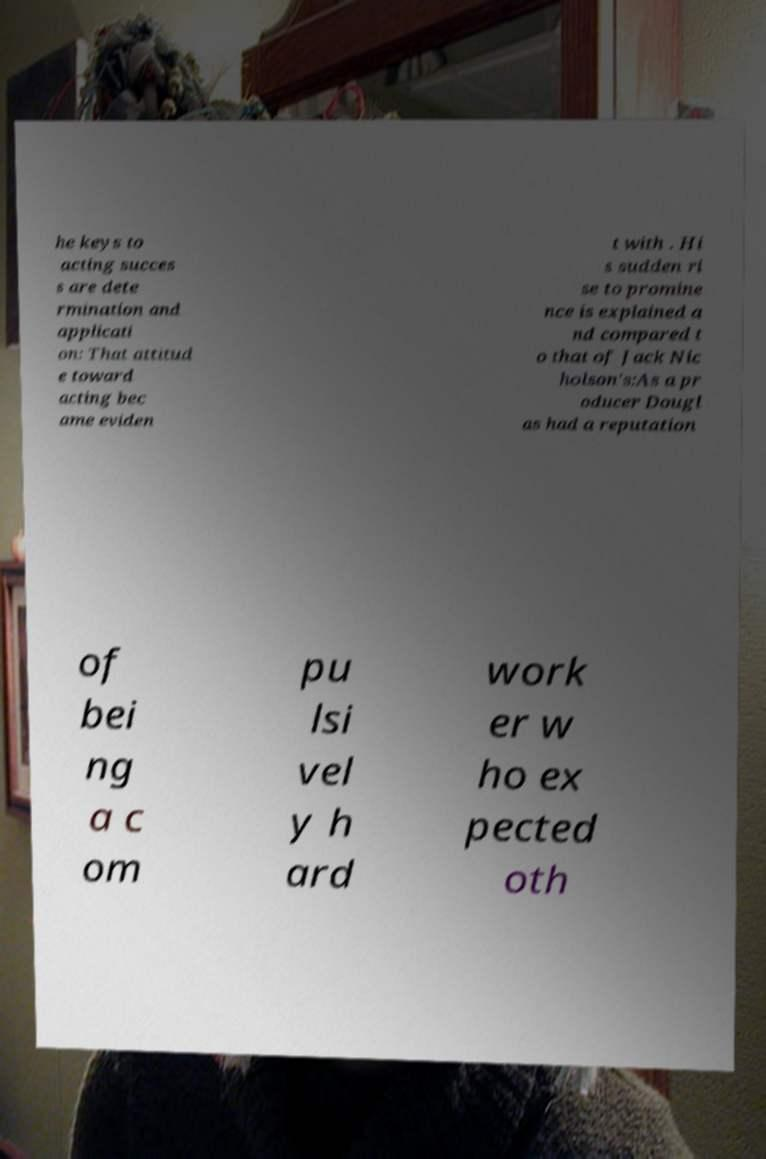What messages or text are displayed in this image? I need them in a readable, typed format. he keys to acting succes s are dete rmination and applicati on: That attitud e toward acting bec ame eviden t with . Hi s sudden ri se to promine nce is explained a nd compared t o that of Jack Nic holson's:As a pr oducer Dougl as had a reputation of bei ng a c om pu lsi vel y h ard work er w ho ex pected oth 